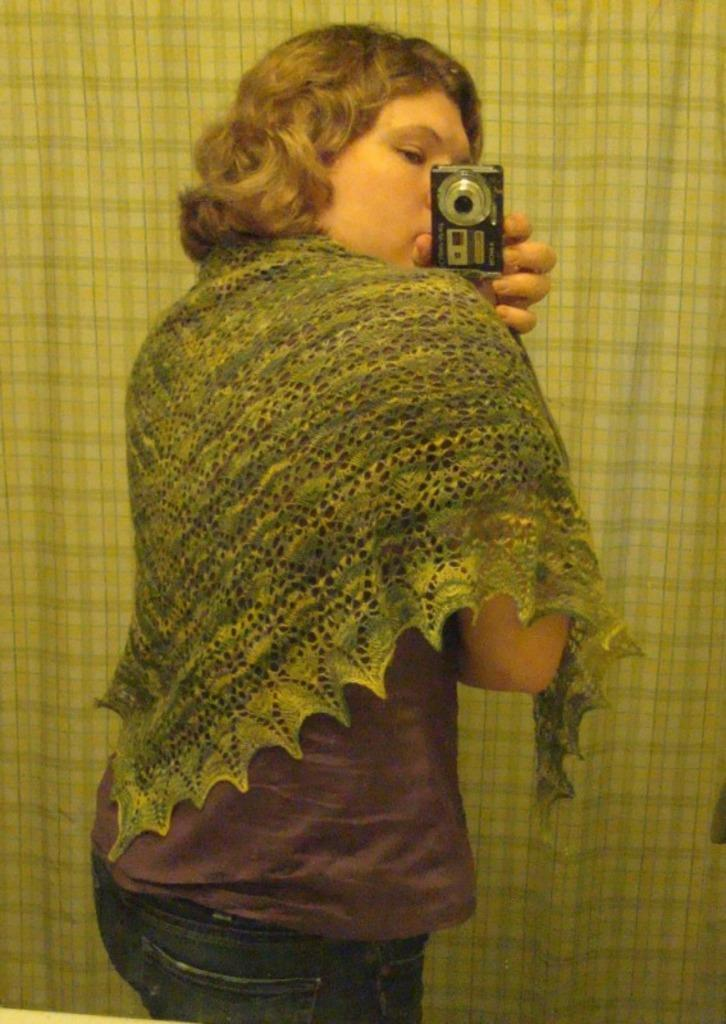Who is the main subject in the image? There is a lady in the image. What is the lady holding in the image? The lady is holding a camera. What is the lady doing with the camera? The lady is taking a picture. What else can be seen in the image besides the lady and the camera? There is cloth visible in the image. Where is the toothbrush located in the image? There is no toothbrush present in the image. What type of doll can be seen sitting on the cushion in the image? There is no doll or cushion present in the image. 